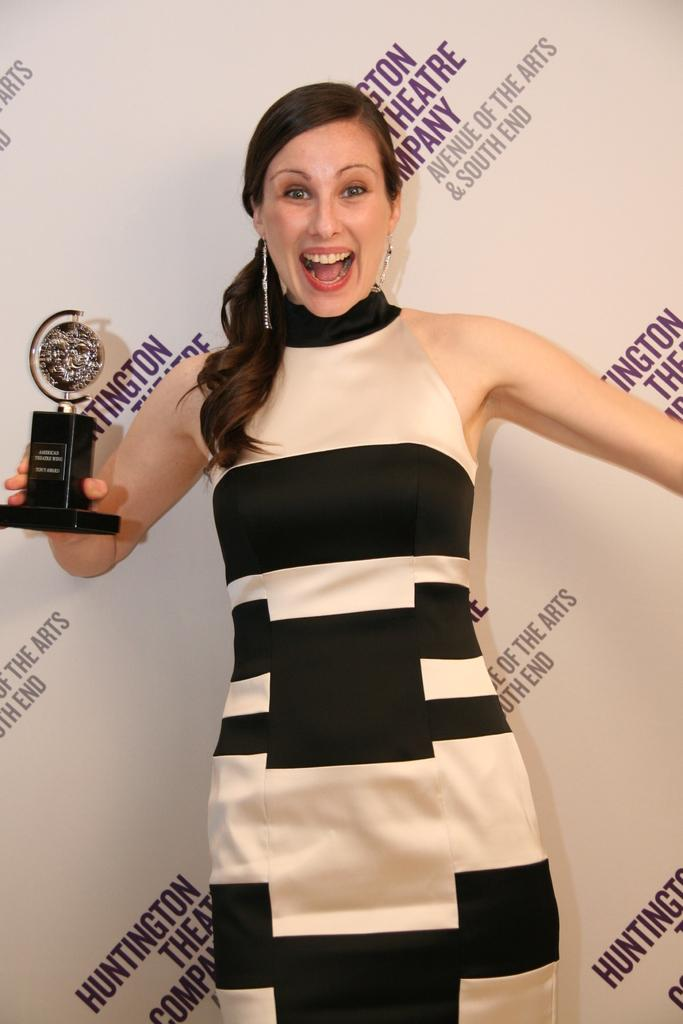Who is the main subject in the image? There is a woman in the image. What is the woman holding in her hand? The woman is holding a trophy in her hand. What is the woman's posture in the image? The woman is standing in the image. What can be seen in the background of the image? There is a banner with text in the background of the image. What type of coal can be seen on the edge of the waves in the image? There is no coal, edge, or waves present in the image. 